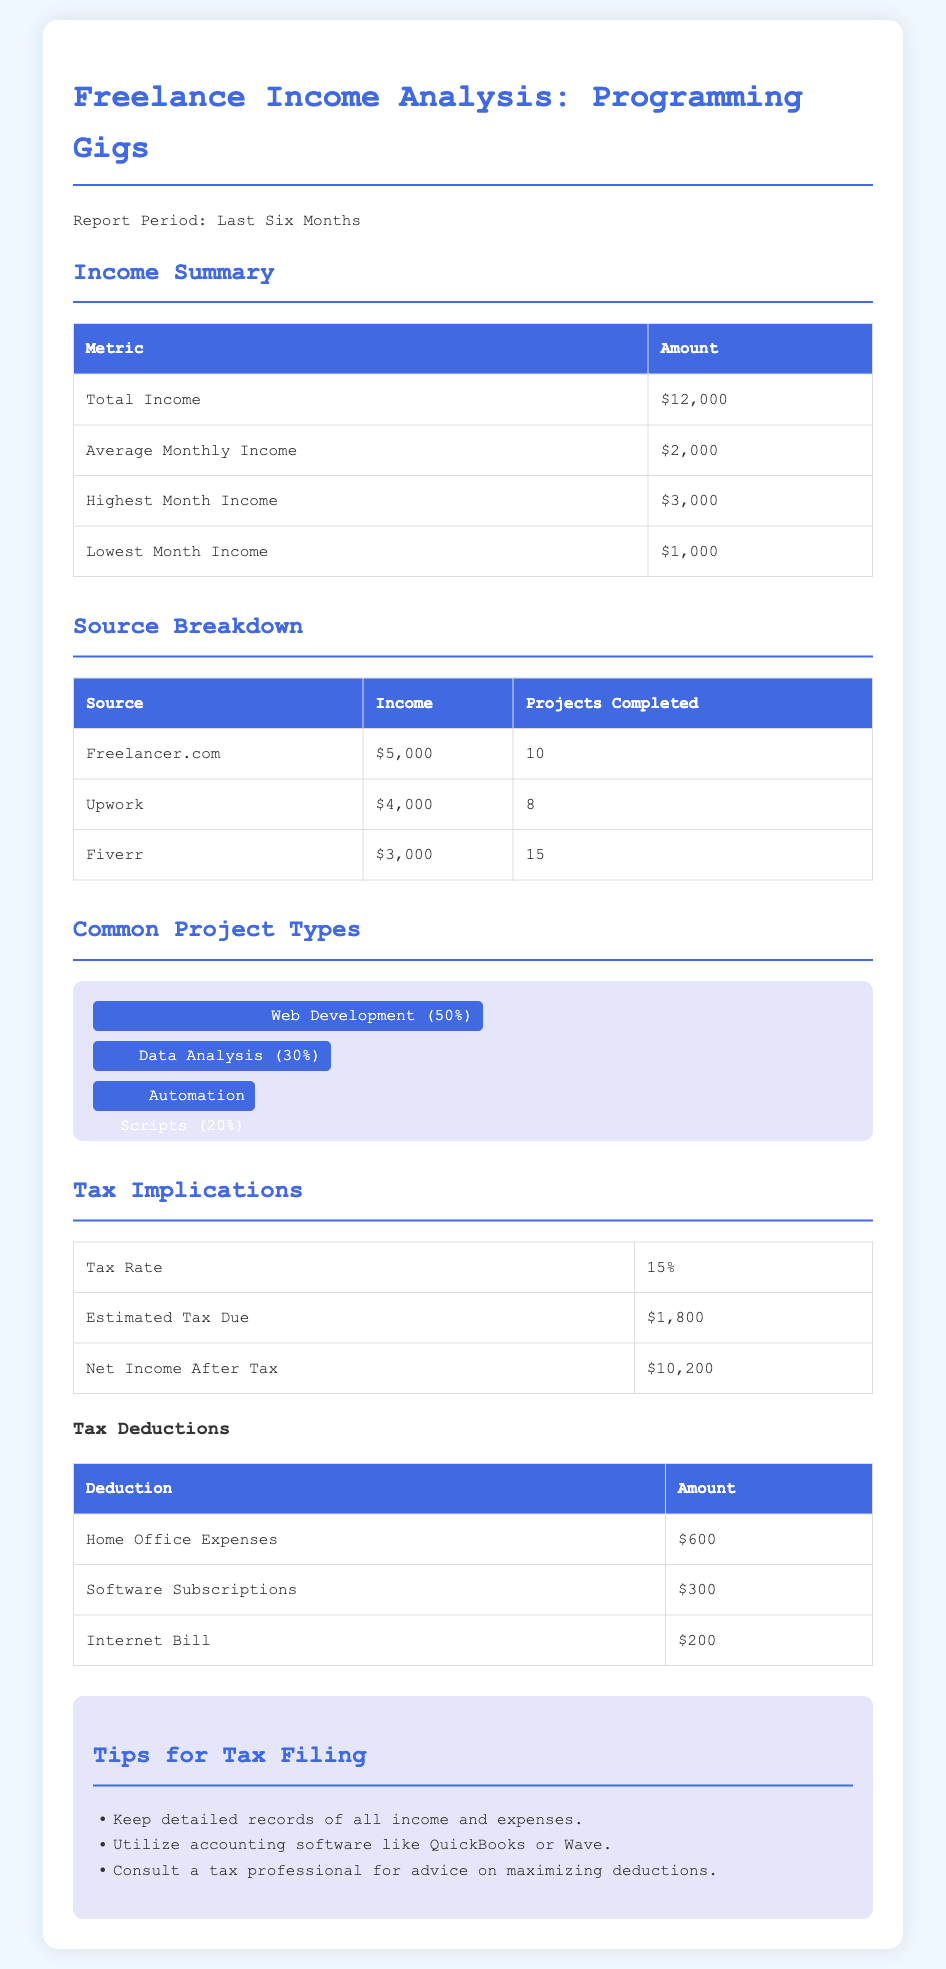What is the total income? The total income is clearly stated in the summary section of the document.
Answer: $12,000 What is the highest month income? The highest month income is detailed in the summary table.
Answer: $3,000 How many projects were completed on Fiverr? The number of projects completed on Fiverr is provided in the source breakdown table.
Answer: 15 What is the tax rate? The tax rate is outlined in the tax implications section.
Answer: 15% What is the net income after tax? The net income after tax can be found in the tax implications table.
Answer: $10,200 Which source generated the least income? The income from each source is listed, allowing us to compare them.
Answer: Fiverr What percentage of common project types is associated with Data Analysis? The percentage breakdown of project types is shown in the chart.
Answer: 30% What amount is allocated for home office expenses as a tax deduction? Tax deductions, including home office expenses, are detailed in a specific table.
Answer: $600 What is the average monthly income? The average monthly income is noted in the income summary table.
Answer: $2,000 